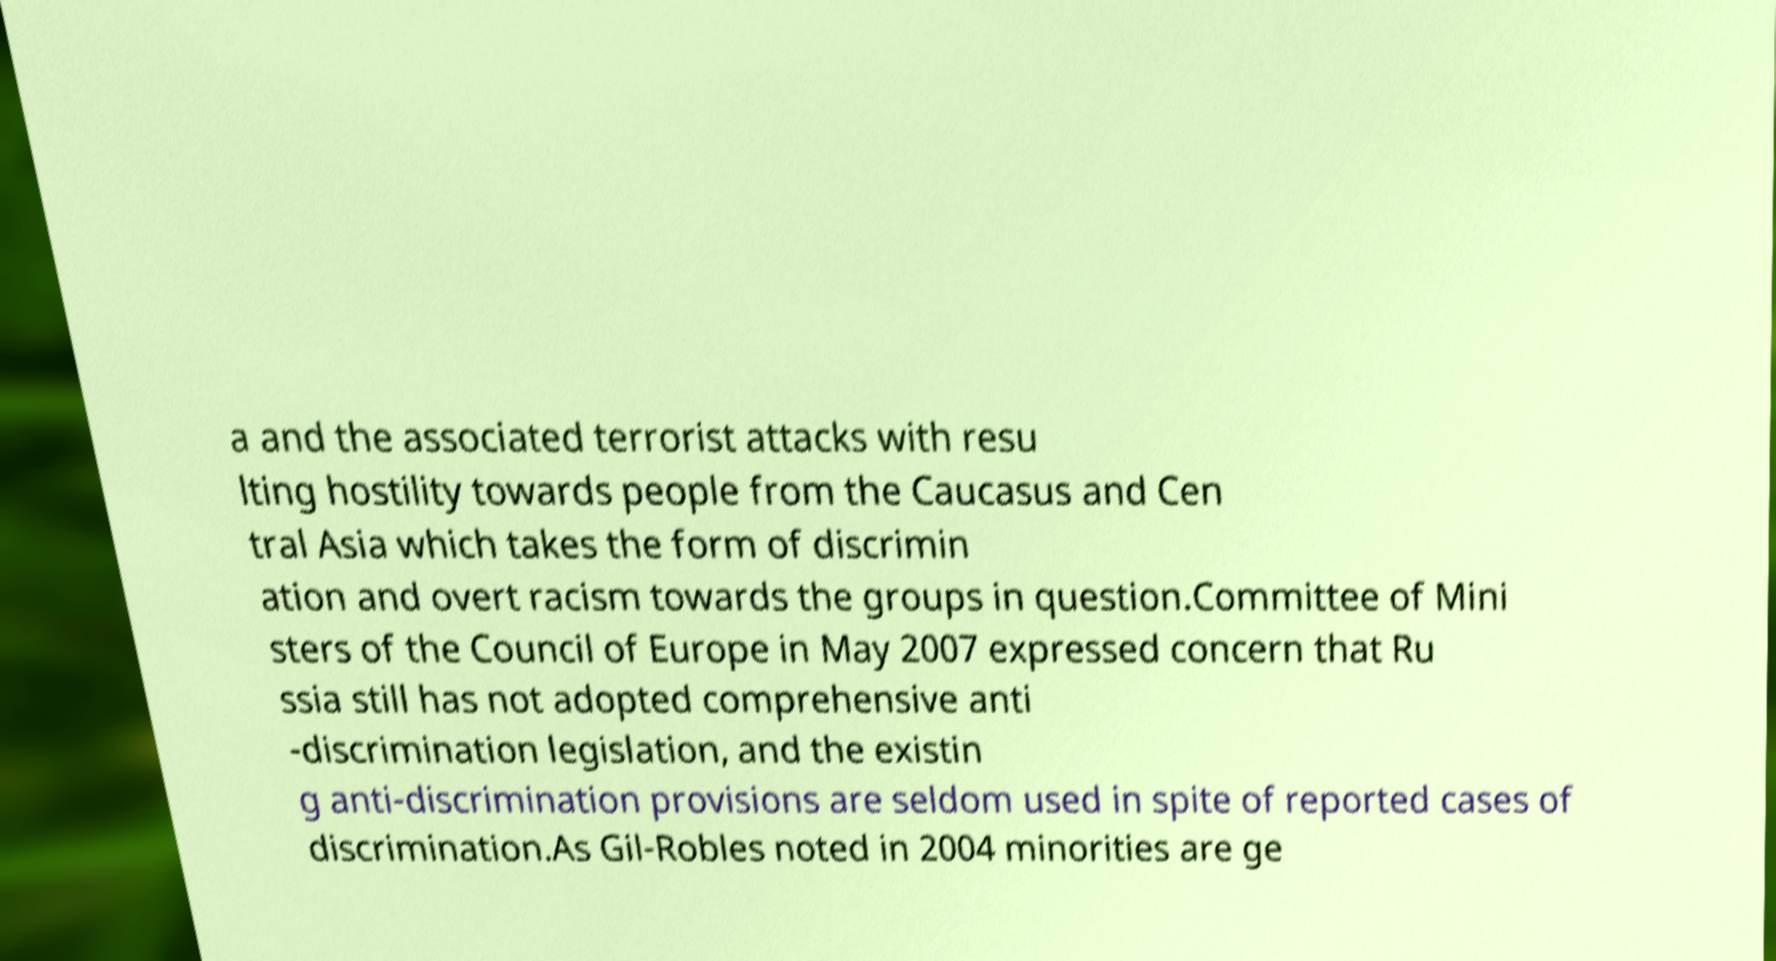Can you accurately transcribe the text from the provided image for me? a and the associated terrorist attacks with resu lting hostility towards people from the Caucasus and Cen tral Asia which takes the form of discrimin ation and overt racism towards the groups in question.Committee of Mini sters of the Council of Europe in May 2007 expressed concern that Ru ssia still has not adopted comprehensive anti -discrimination legislation, and the existin g anti-discrimination provisions are seldom used in spite of reported cases of discrimination.As Gil-Robles noted in 2004 minorities are ge 